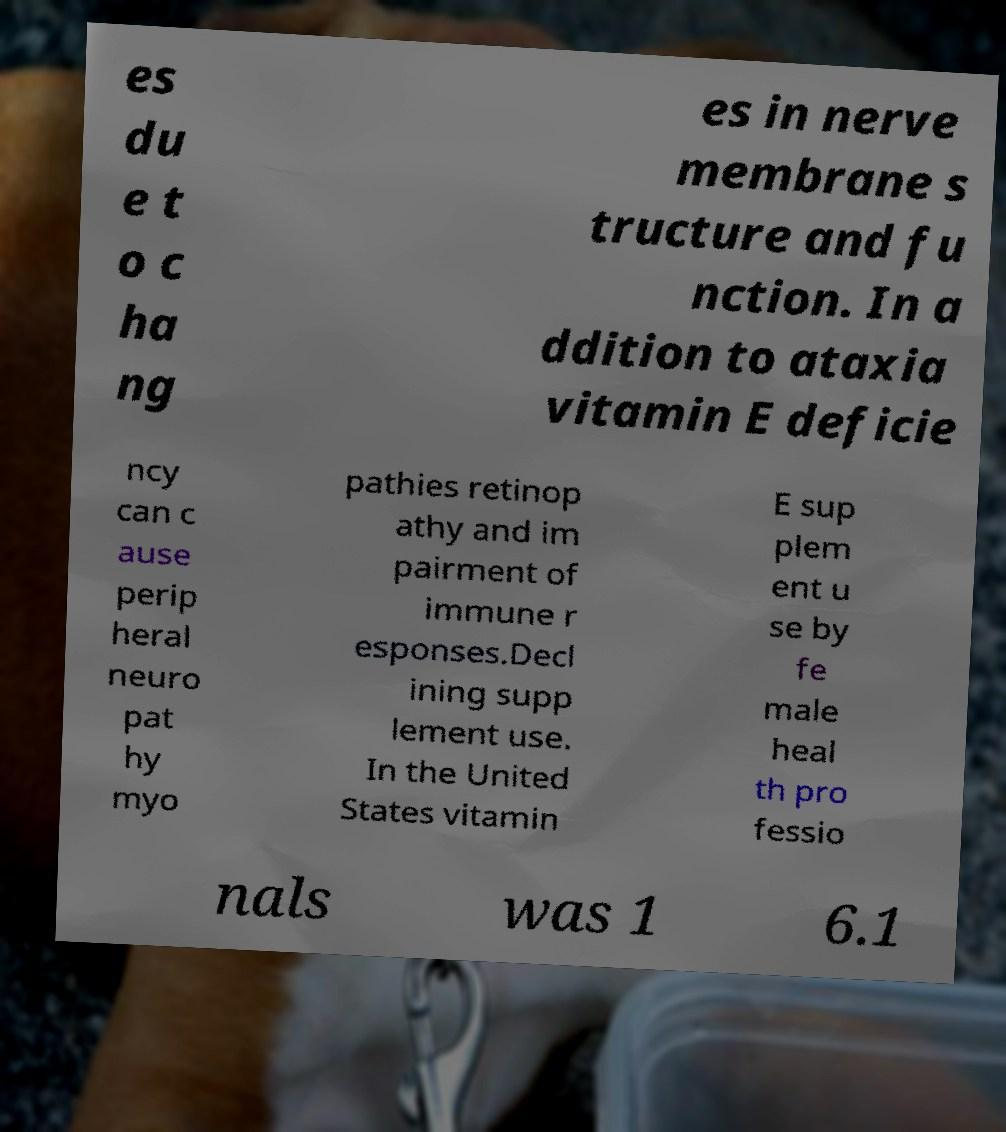Can you accurately transcribe the text from the provided image for me? es du e t o c ha ng es in nerve membrane s tructure and fu nction. In a ddition to ataxia vitamin E deficie ncy can c ause perip heral neuro pat hy myo pathies retinop athy and im pairment of immune r esponses.Decl ining supp lement use. In the United States vitamin E sup plem ent u se by fe male heal th pro fessio nals was 1 6.1 